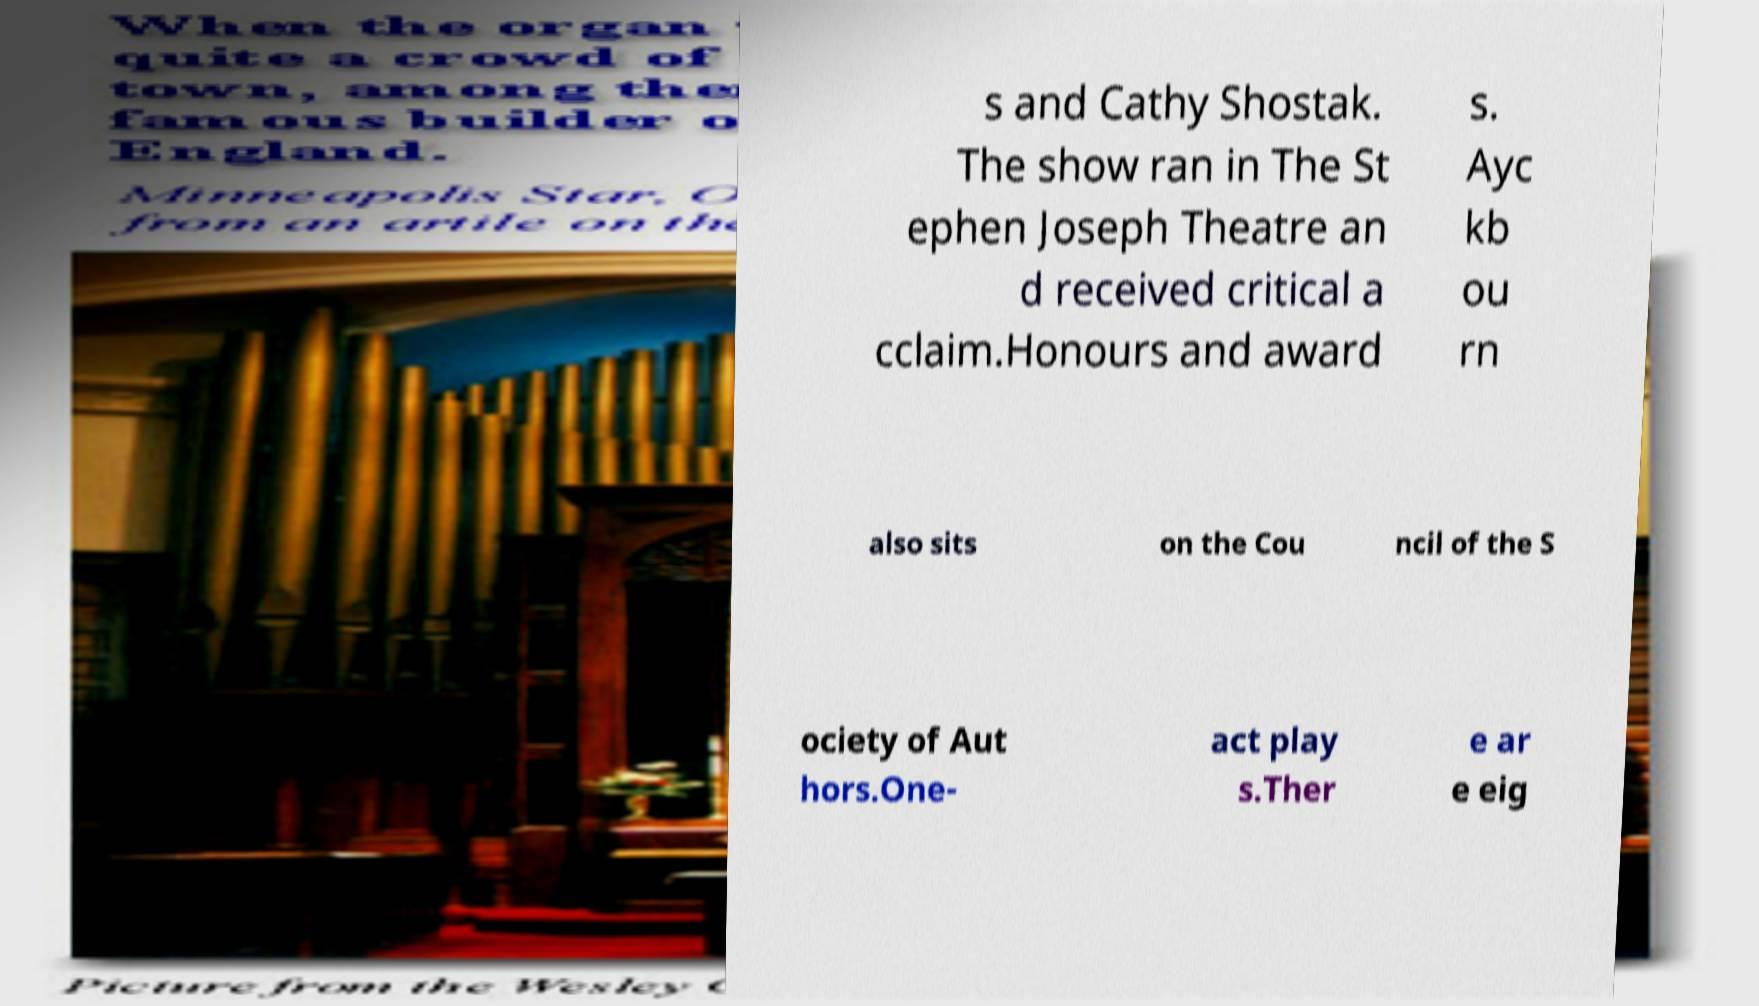Could you extract and type out the text from this image? s and Cathy Shostak. The show ran in The St ephen Joseph Theatre an d received critical a cclaim.Honours and award s. Ayc kb ou rn also sits on the Cou ncil of the S ociety of Aut hors.One- act play s.Ther e ar e eig 